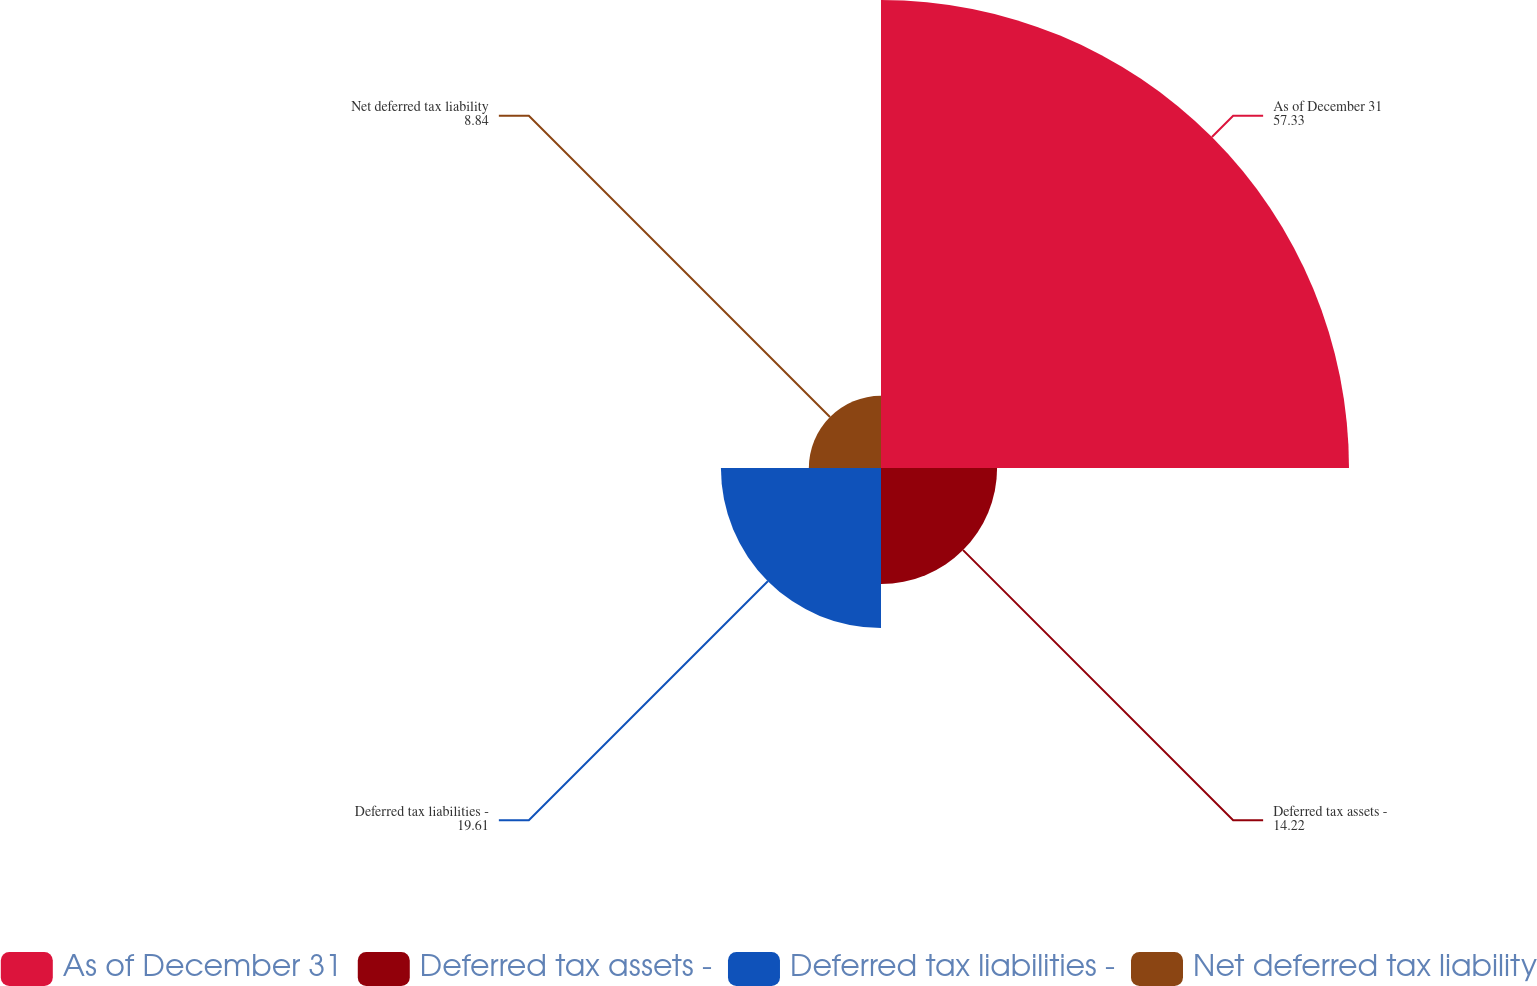Convert chart. <chart><loc_0><loc_0><loc_500><loc_500><pie_chart><fcel>As of December 31<fcel>Deferred tax assets -<fcel>Deferred tax liabilities -<fcel>Net deferred tax liability<nl><fcel>57.33%<fcel>14.22%<fcel>19.61%<fcel>8.84%<nl></chart> 